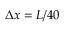Convert formula to latex. <formula><loc_0><loc_0><loc_500><loc_500>\Delta x = L / 4 0</formula> 